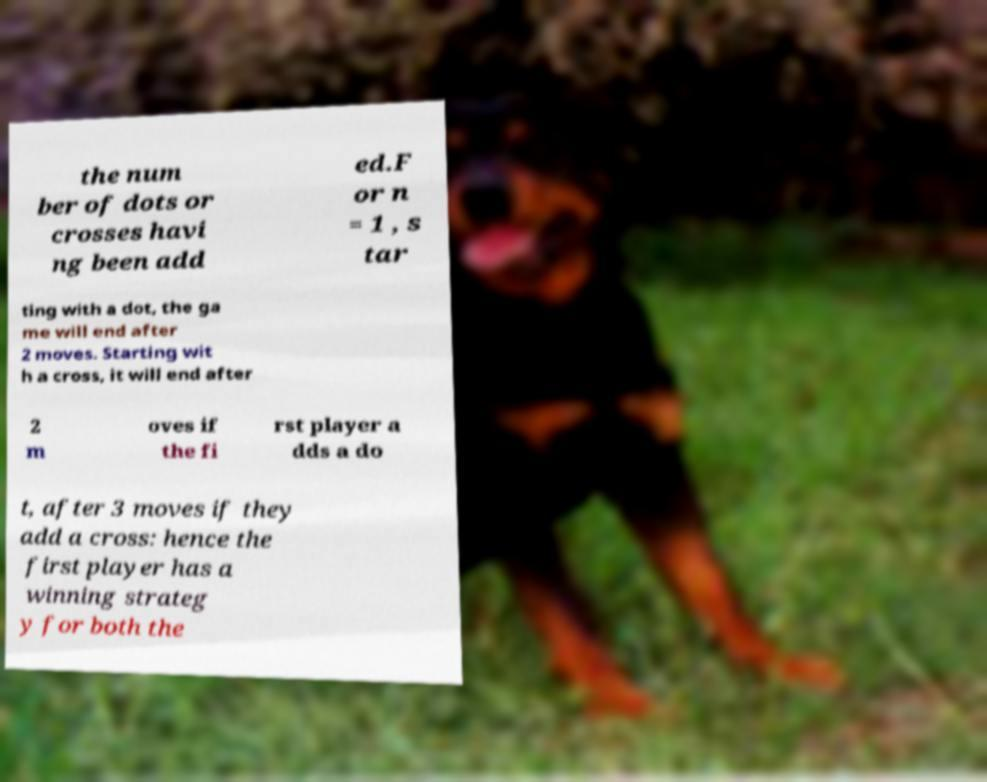Can you read and provide the text displayed in the image?This photo seems to have some interesting text. Can you extract and type it out for me? the num ber of dots or crosses havi ng been add ed.F or n = 1 , s tar ting with a dot, the ga me will end after 2 moves. Starting wit h a cross, it will end after 2 m oves if the fi rst player a dds a do t, after 3 moves if they add a cross: hence the first player has a winning strateg y for both the 